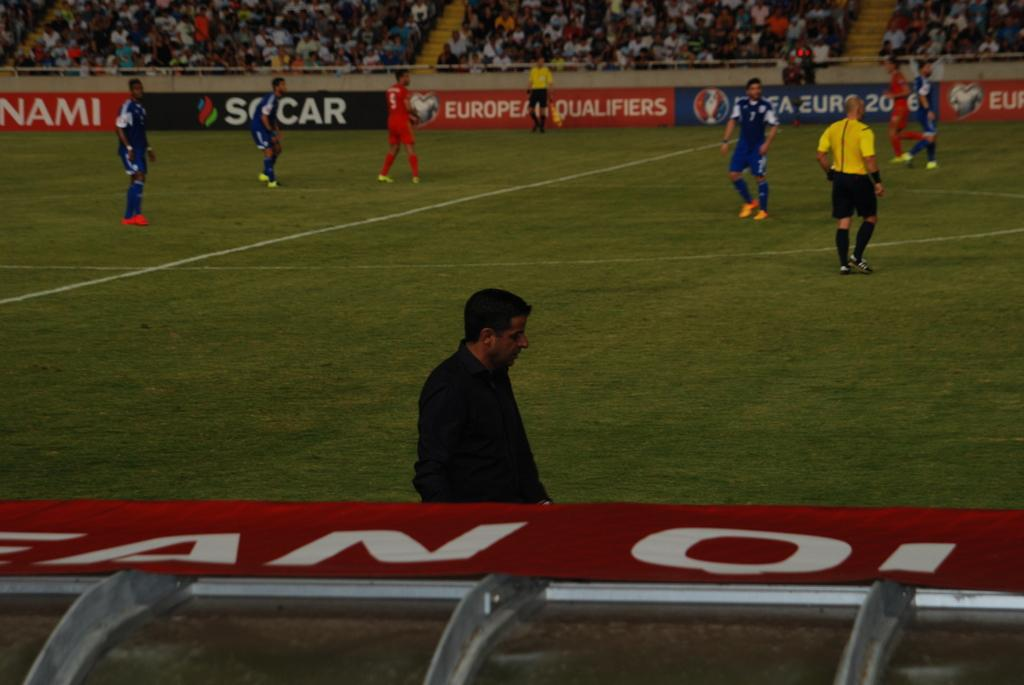What is happening on the ground in the image? There are people on the ground in the image. What can be seen in the background of the image? There are boards and a stadium with people sitting in it visible in the background of the image. What type of shock can be seen happening to the people on the ground in the image? There is no shock visible in the image; it simply shows people on the ground and a stadium in the background. How many weeks have passed since the event depicted in the image? The image does not provide any information about the timing or duration of the event, so it is impossible to determine how many weeks have passed. 